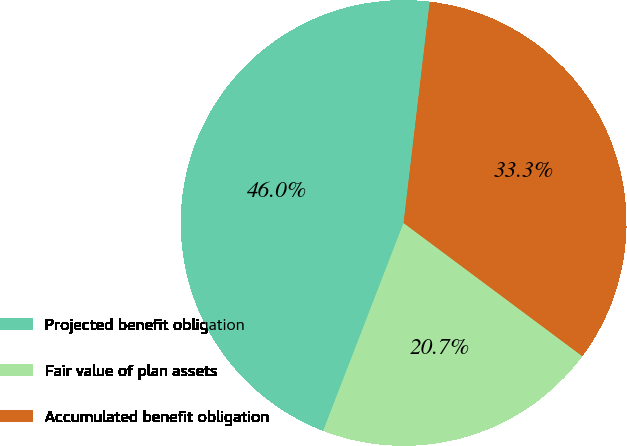Convert chart. <chart><loc_0><loc_0><loc_500><loc_500><pie_chart><fcel>Projected benefit obligation<fcel>Fair value of plan assets<fcel>Accumulated benefit obligation<nl><fcel>46.0%<fcel>20.68%<fcel>33.32%<nl></chart> 